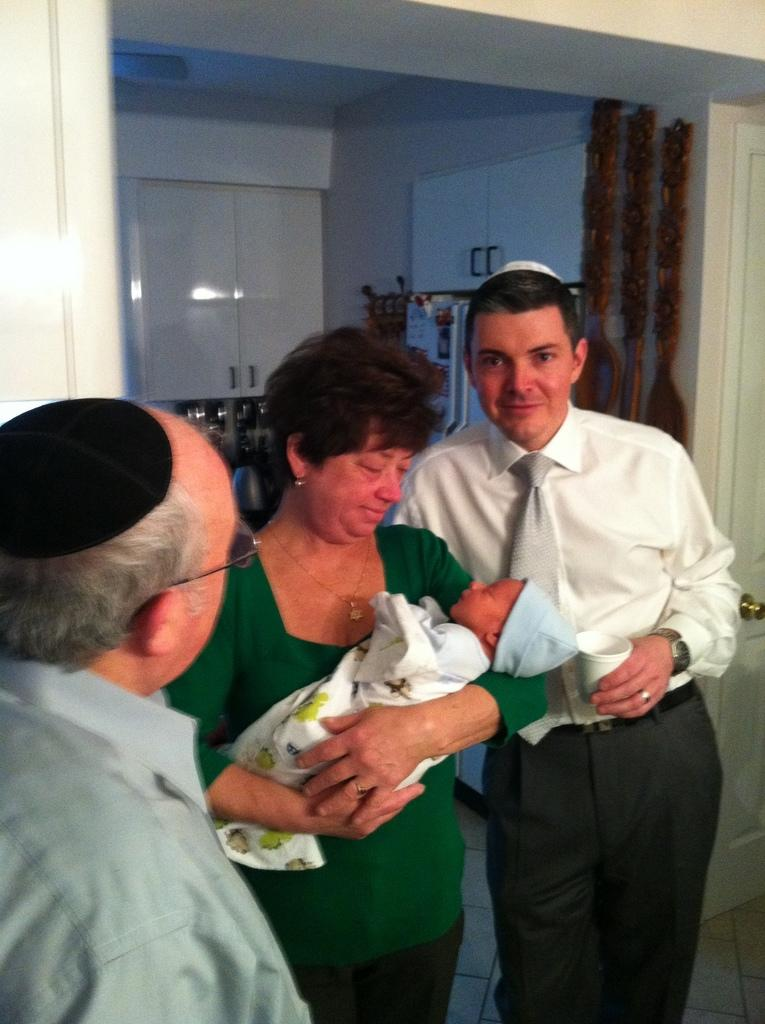Who is the main subject in the image? There is a woman in the image. What is the woman doing in the image? The woman is holding a baby. How many men are present in the image? There are two men in the image. Where are the men standing in the image? The men are standing on the floor. What can be seen in the background of the image? There are doors, walls, cupboards, and some crockery visible in the background of the image. What team is playing in the background of the image? There is no team playing in the background of the image; it features a woman holding a baby and two men standing on the floor, with doors, walls, cupboards, and crockery visible in the background. 